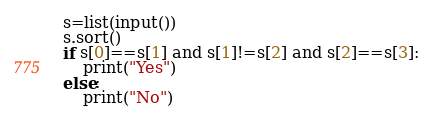Convert code to text. <code><loc_0><loc_0><loc_500><loc_500><_Python_>s=list(input())
s.sort()
if s[0]==s[1] and s[1]!=s[2] and s[2]==s[3]:
    print("Yes")
else:
    print("No")</code> 